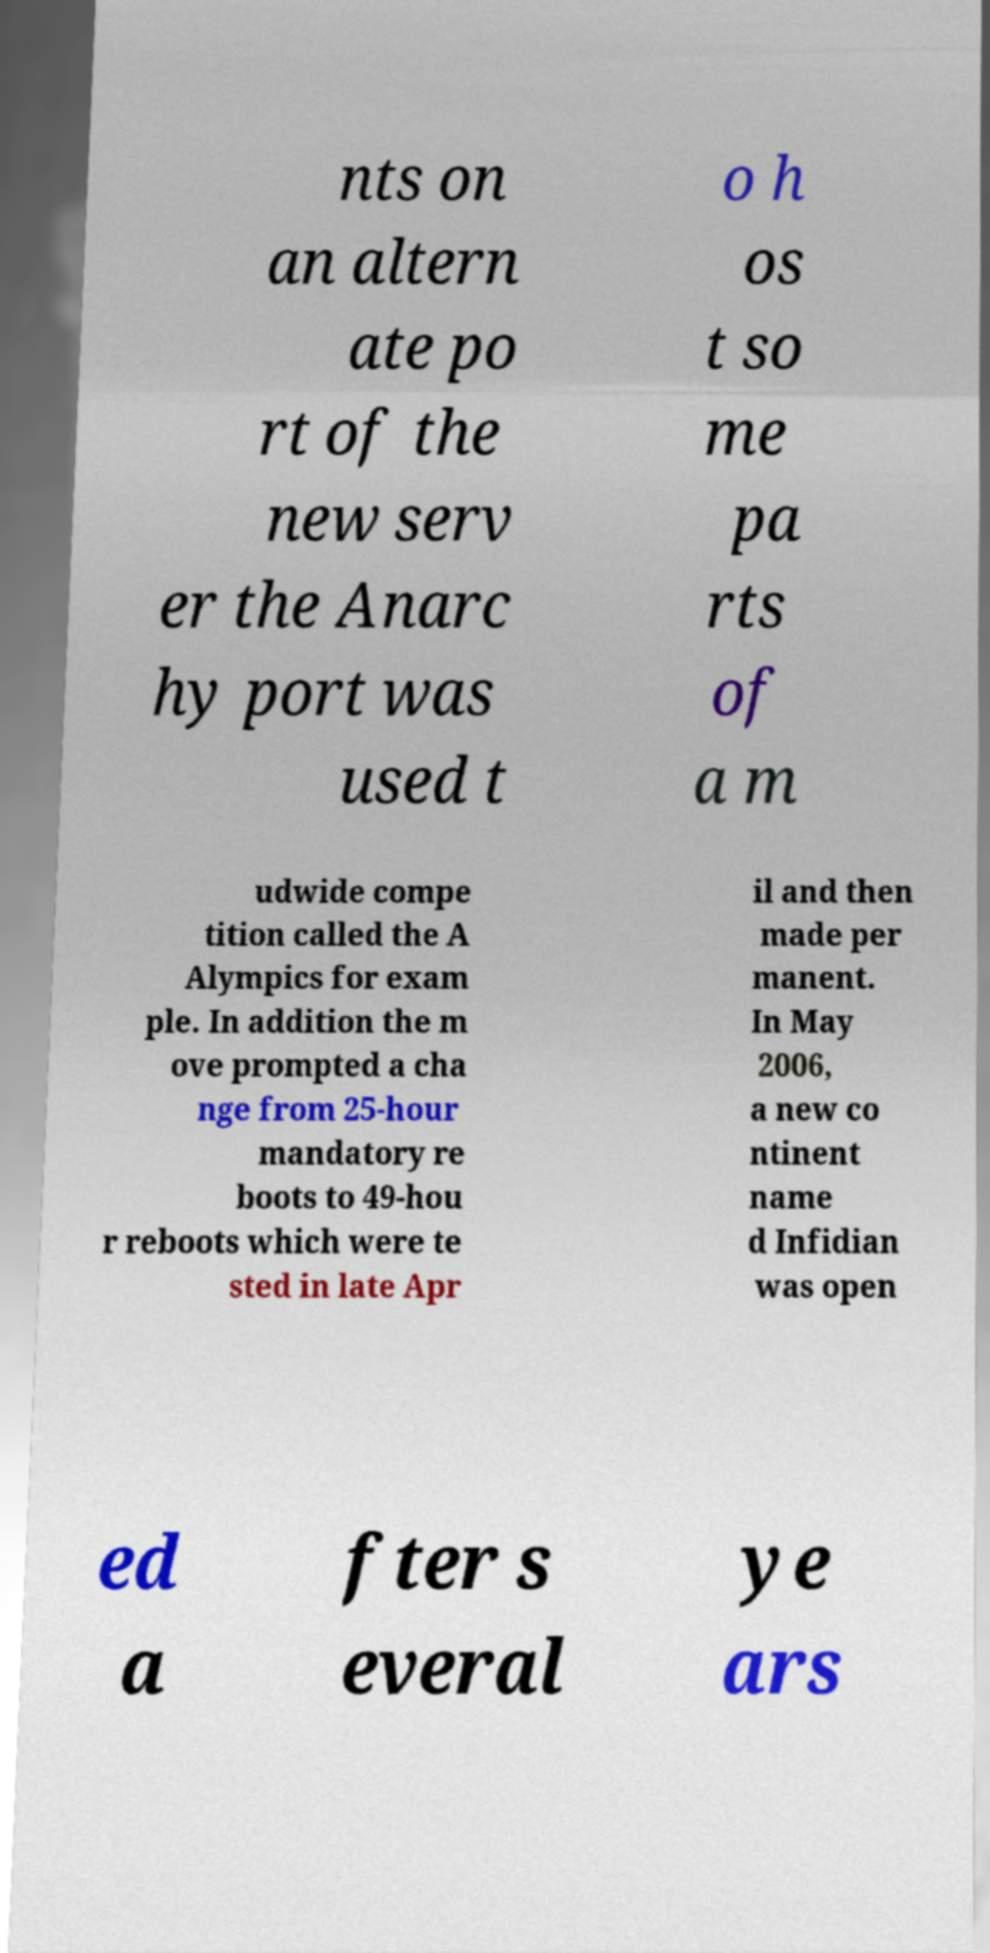I need the written content from this picture converted into text. Can you do that? nts on an altern ate po rt of the new serv er the Anarc hy port was used t o h os t so me pa rts of a m udwide compe tition called the A Alympics for exam ple. In addition the m ove prompted a cha nge from 25-hour mandatory re boots to 49-hou r reboots which were te sted in late Apr il and then made per manent. In May 2006, a new co ntinent name d Infidian was open ed a fter s everal ye ars 